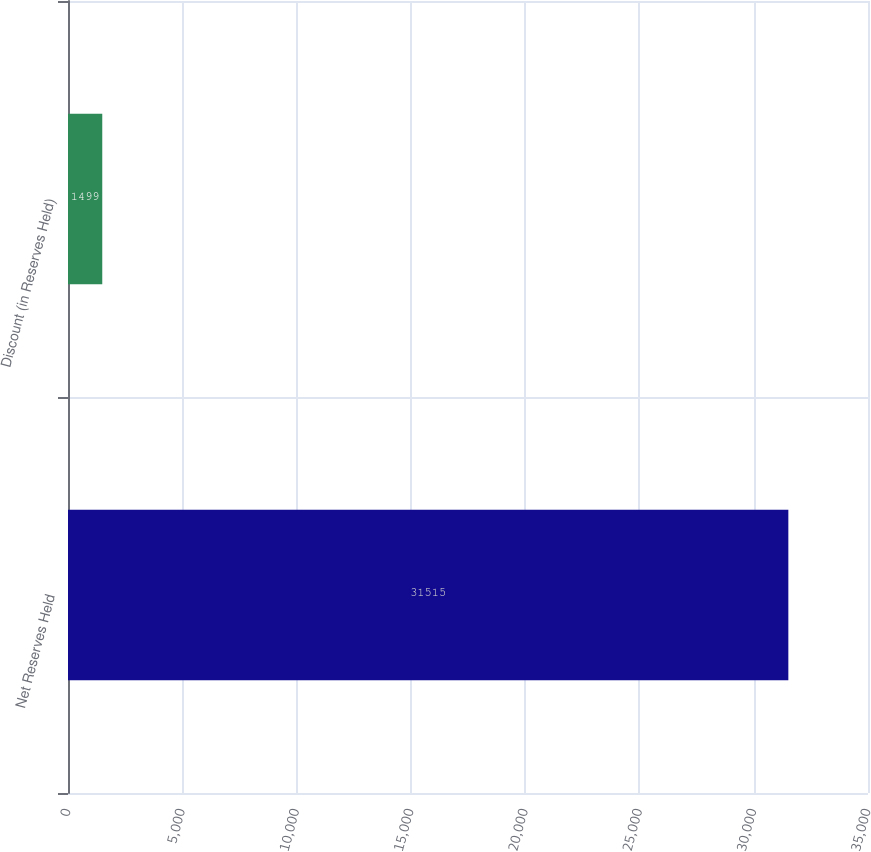<chart> <loc_0><loc_0><loc_500><loc_500><bar_chart><fcel>Net Reserves Held<fcel>Discount (in Reserves Held)<nl><fcel>31515<fcel>1499<nl></chart> 